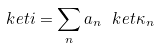<formula> <loc_0><loc_0><loc_500><loc_500>\ k e t { i } = \sum _ { n } a _ { n } \ k e t { \kappa _ { n } }</formula> 